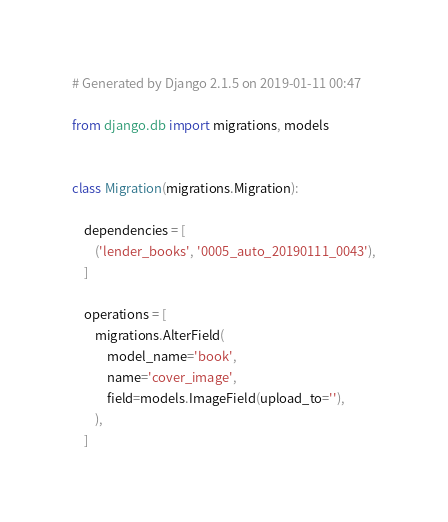Convert code to text. <code><loc_0><loc_0><loc_500><loc_500><_Python_># Generated by Django 2.1.5 on 2019-01-11 00:47

from django.db import migrations, models


class Migration(migrations.Migration):

    dependencies = [
        ('lender_books', '0005_auto_20190111_0043'),
    ]

    operations = [
        migrations.AlterField(
            model_name='book',
            name='cover_image',
            field=models.ImageField(upload_to=''),
        ),
    ]
</code> 